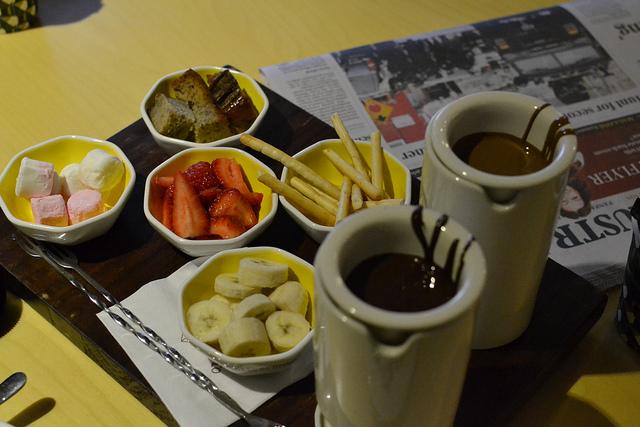What color is the plate?
Write a very short answer. Brown. Is the fruit whole or cut up?
Write a very short answer. Cut up. Is the food fresh?
Concise answer only. Yes. Is this an English newspaper?
Write a very short answer. Yes. What shape are the yellow bowls?
Quick response, please. Octagon. 